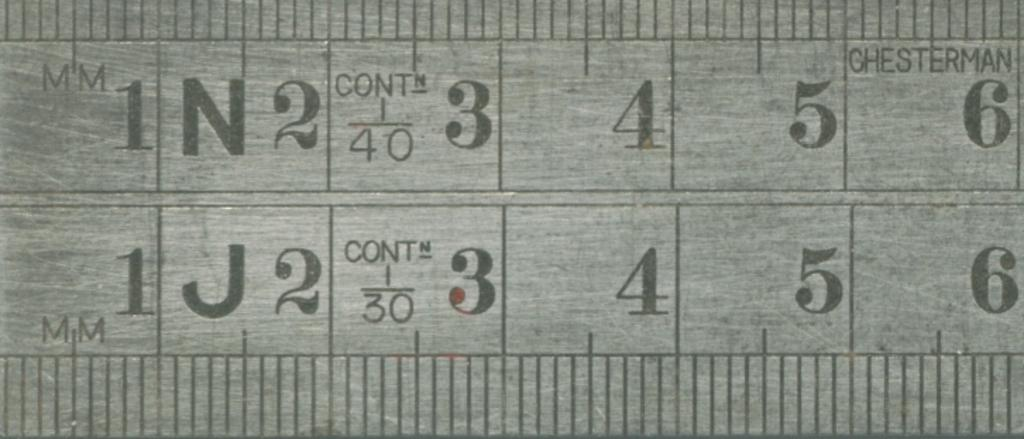Provide a one-sentence caption for the provided image. Close up of a metal millimeter ruler showing zero through six. 